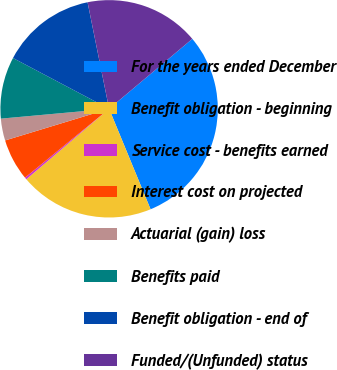Convert chart to OTSL. <chart><loc_0><loc_0><loc_500><loc_500><pie_chart><fcel>For the years ended December<fcel>Benefit obligation - beginning<fcel>Service cost - benefits earned<fcel>Interest cost on projected<fcel>Actuarial (gain) loss<fcel>Benefits paid<fcel>Benefit obligation - end of<fcel>Funded/(Unfunded) status<nl><fcel>29.9%<fcel>20.01%<fcel>0.3%<fcel>6.22%<fcel>3.26%<fcel>9.18%<fcel>14.09%<fcel>17.05%<nl></chart> 